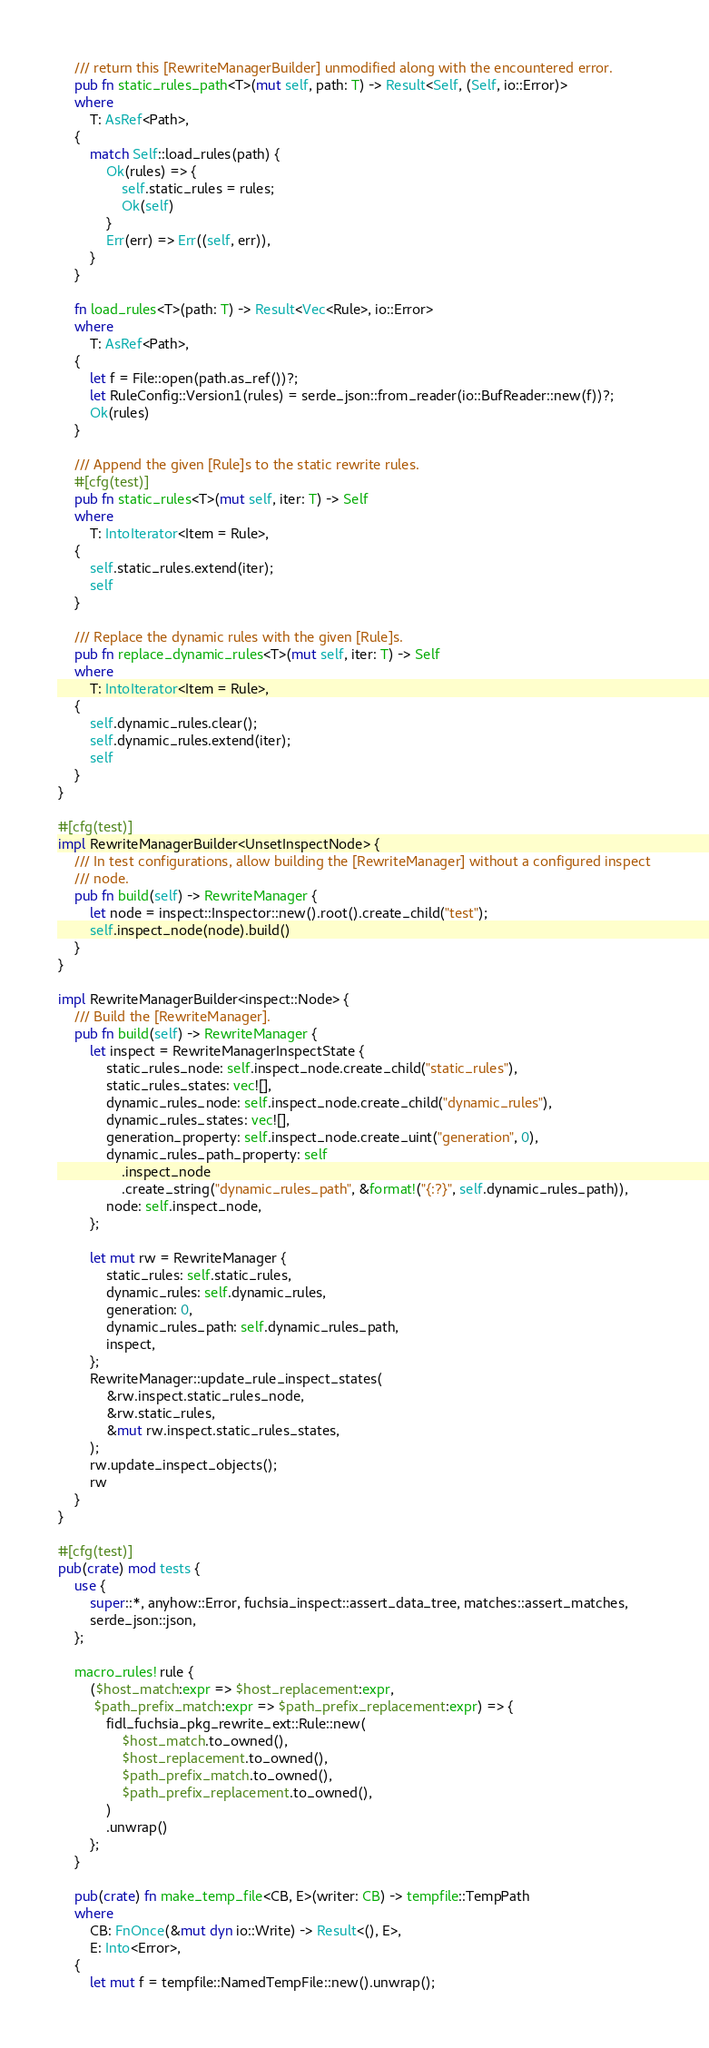<code> <loc_0><loc_0><loc_500><loc_500><_Rust_>    /// return this [RewriteManagerBuilder] unmodified along with the encountered error.
    pub fn static_rules_path<T>(mut self, path: T) -> Result<Self, (Self, io::Error)>
    where
        T: AsRef<Path>,
    {
        match Self::load_rules(path) {
            Ok(rules) => {
                self.static_rules = rules;
                Ok(self)
            }
            Err(err) => Err((self, err)),
        }
    }

    fn load_rules<T>(path: T) -> Result<Vec<Rule>, io::Error>
    where
        T: AsRef<Path>,
    {
        let f = File::open(path.as_ref())?;
        let RuleConfig::Version1(rules) = serde_json::from_reader(io::BufReader::new(f))?;
        Ok(rules)
    }

    /// Append the given [Rule]s to the static rewrite rules.
    #[cfg(test)]
    pub fn static_rules<T>(mut self, iter: T) -> Self
    where
        T: IntoIterator<Item = Rule>,
    {
        self.static_rules.extend(iter);
        self
    }

    /// Replace the dynamic rules with the given [Rule]s.
    pub fn replace_dynamic_rules<T>(mut self, iter: T) -> Self
    where
        T: IntoIterator<Item = Rule>,
    {
        self.dynamic_rules.clear();
        self.dynamic_rules.extend(iter);
        self
    }
}

#[cfg(test)]
impl RewriteManagerBuilder<UnsetInspectNode> {
    /// In test configurations, allow building the [RewriteManager] without a configured inspect
    /// node.
    pub fn build(self) -> RewriteManager {
        let node = inspect::Inspector::new().root().create_child("test");
        self.inspect_node(node).build()
    }
}

impl RewriteManagerBuilder<inspect::Node> {
    /// Build the [RewriteManager].
    pub fn build(self) -> RewriteManager {
        let inspect = RewriteManagerInspectState {
            static_rules_node: self.inspect_node.create_child("static_rules"),
            static_rules_states: vec![],
            dynamic_rules_node: self.inspect_node.create_child("dynamic_rules"),
            dynamic_rules_states: vec![],
            generation_property: self.inspect_node.create_uint("generation", 0),
            dynamic_rules_path_property: self
                .inspect_node
                .create_string("dynamic_rules_path", &format!("{:?}", self.dynamic_rules_path)),
            node: self.inspect_node,
        };

        let mut rw = RewriteManager {
            static_rules: self.static_rules,
            dynamic_rules: self.dynamic_rules,
            generation: 0,
            dynamic_rules_path: self.dynamic_rules_path,
            inspect,
        };
        RewriteManager::update_rule_inspect_states(
            &rw.inspect.static_rules_node,
            &rw.static_rules,
            &mut rw.inspect.static_rules_states,
        );
        rw.update_inspect_objects();
        rw
    }
}

#[cfg(test)]
pub(crate) mod tests {
    use {
        super::*, anyhow::Error, fuchsia_inspect::assert_data_tree, matches::assert_matches,
        serde_json::json,
    };

    macro_rules! rule {
        ($host_match:expr => $host_replacement:expr,
         $path_prefix_match:expr => $path_prefix_replacement:expr) => {
            fidl_fuchsia_pkg_rewrite_ext::Rule::new(
                $host_match.to_owned(),
                $host_replacement.to_owned(),
                $path_prefix_match.to_owned(),
                $path_prefix_replacement.to_owned(),
            )
            .unwrap()
        };
    }

    pub(crate) fn make_temp_file<CB, E>(writer: CB) -> tempfile::TempPath
    where
        CB: FnOnce(&mut dyn io::Write) -> Result<(), E>,
        E: Into<Error>,
    {
        let mut f = tempfile::NamedTempFile::new().unwrap();</code> 